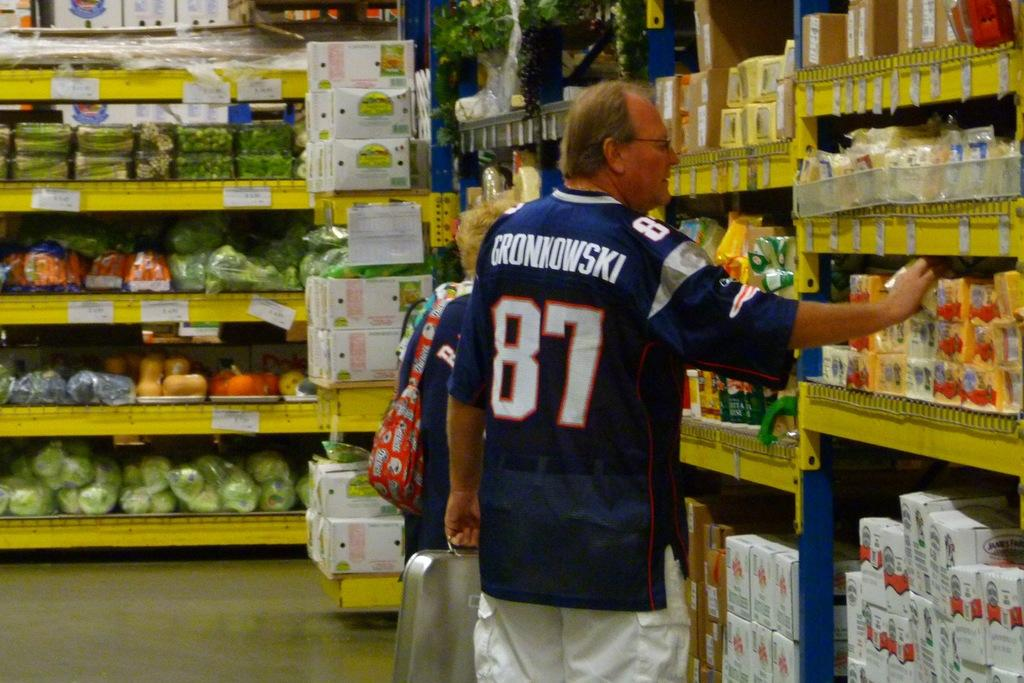<image>
Render a clear and concise summary of the photo. A man with a jersey that says Gronkowski is shopping in a store. 